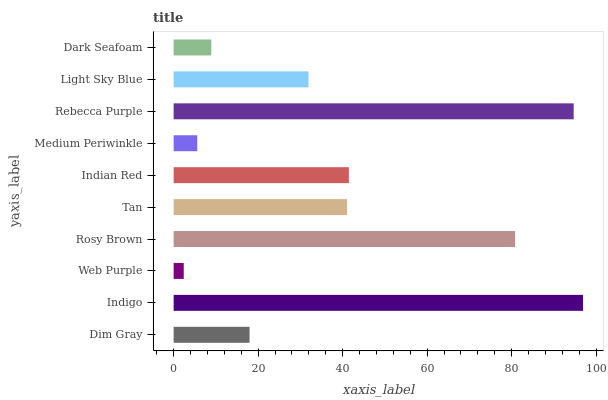Is Web Purple the minimum?
Answer yes or no. Yes. Is Indigo the maximum?
Answer yes or no. Yes. Is Indigo the minimum?
Answer yes or no. No. Is Web Purple the maximum?
Answer yes or no. No. Is Indigo greater than Web Purple?
Answer yes or no. Yes. Is Web Purple less than Indigo?
Answer yes or no. Yes. Is Web Purple greater than Indigo?
Answer yes or no. No. Is Indigo less than Web Purple?
Answer yes or no. No. Is Tan the high median?
Answer yes or no. Yes. Is Light Sky Blue the low median?
Answer yes or no. Yes. Is Dim Gray the high median?
Answer yes or no. No. Is Rosy Brown the low median?
Answer yes or no. No. 